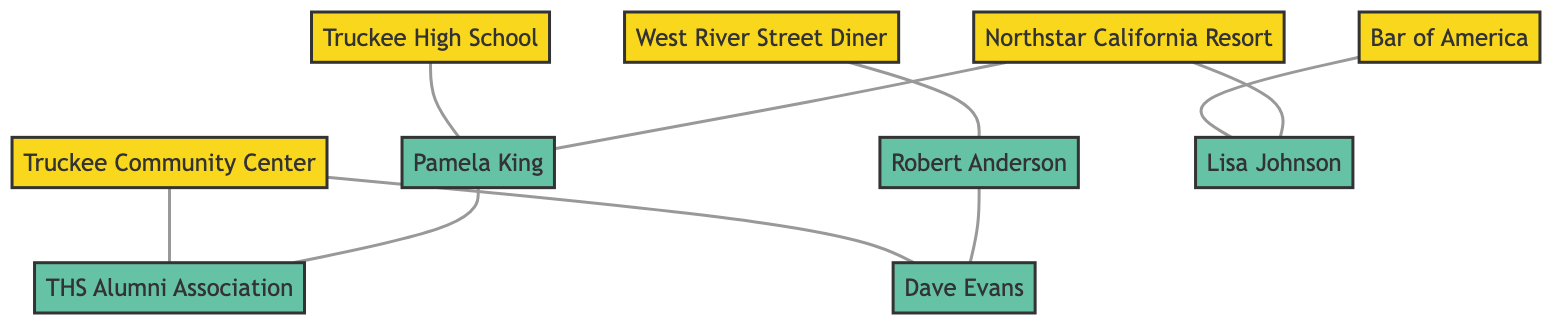What are the gathering spots in the diagram? The nodes labeled as gathering spots include Truckee High School, West River Street Diner, Bar of America, Truckee Community Center, and Northstar California Resort. These nodes represent locations where fans and supporters gather.
Answer: Truckee High School, West River Street Diner, Bar of America, Truckee Community Center, Northstar California Resort Who is connected to Truckee High School? The diagram shows that Pamela King is directly connected to Truckee High School by an edge, indicating a relationship or a connection between them.
Answer: Pamela King How many key supporters are listed in the diagram? By identifying the nodes marked as key supporters—Pamela King, Robert Anderson, Lisa Johnson, and Dave Evans—we find there are a total of four key supporters.
Answer: 4 Which gathering spot is linked to both Pamela King and Lisa Johnson? Examining the edges, Northstar California Resort connects to both Pamela King and Lisa Johnson, demonstrating that this gathering spot serves as a common link between them.
Answer: Northstar California Resort What community figure is associated with Truckee Community Center? The edge from Truckee Community Center to Truckee High School Alumni Association indicates that the association is tied to the community center, showing it is a related entity.
Answer: Truckee High School Alumni Association How many edges connect to Truckee Community Center? By counting the edges, we see that Truckee Community Center has two direct connections—one to Truckee High School Alumni Association and one to Dave Evans—resulting in a total of two edges.
Answer: 2 Which key supporter has connections to both West River Street Diner and Truckee Community Center? Looking at the edges, Robert Anderson is directly connected to West River Street Diner, while he is also linked to Dave Evans, who connects to Truckee Community Center, revealing a broader network relationship via Robert Anderson himself.
Answer: Robert Anderson What is the relationship between Pamela King and the Truckee High School Alumni Association? There is a direct edge that links Pamela King to the Truckee High School Alumni Association, indicating a close relationship between these two entities.
Answer: Relationship Which gathering spot is directly linked to the most key supporters? By analyzing the connections, we note that Northstar California Resort is linked to two key supporters: Pamela King and Lisa Johnson. This is more than any other gathering spot in the diagram.
Answer: Northstar California Resort 